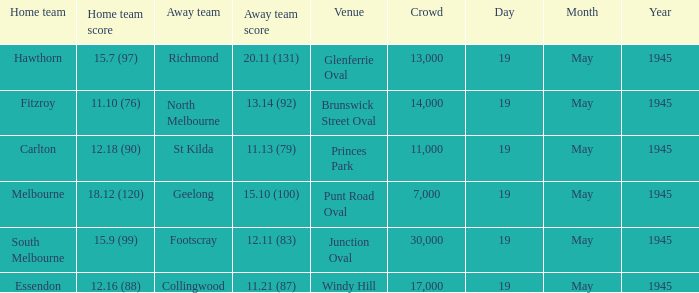On which date was a game played at Junction Oval? 19 May 1945. 